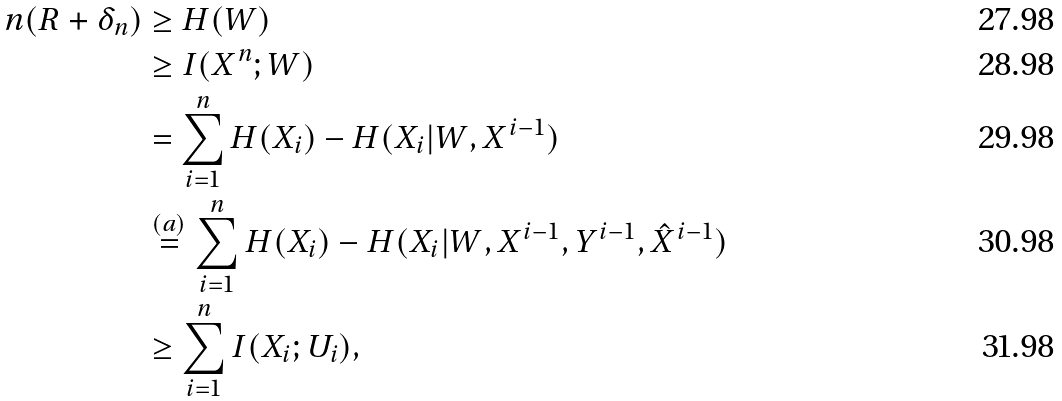Convert formula to latex. <formula><loc_0><loc_0><loc_500><loc_500>n ( R + \delta _ { n } ) & \geq H ( W ) \\ & \geq I ( X ^ { n } ; W ) \\ & = \sum _ { i = 1 } ^ { n } H ( X _ { i } ) - H ( X _ { i } | W , X ^ { i - 1 } ) \\ & \overset { ( a ) } { = } \sum _ { i = 1 } ^ { n } H ( X _ { i } ) - H ( X _ { i } | W , X ^ { i - 1 } , Y ^ { i - 1 } , \hat { X } ^ { i - 1 } ) \\ & \geq \sum _ { i = 1 } ^ { n } I ( X _ { i } ; U _ { i } ) ,</formula> 